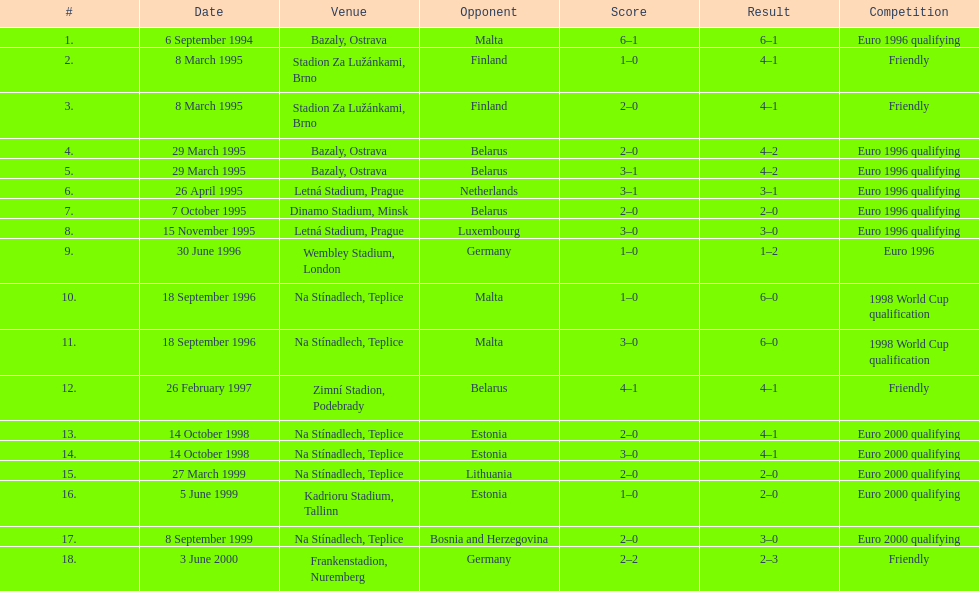What venue is listed above wembley stadium, london? Letná Stadium, Prague. 